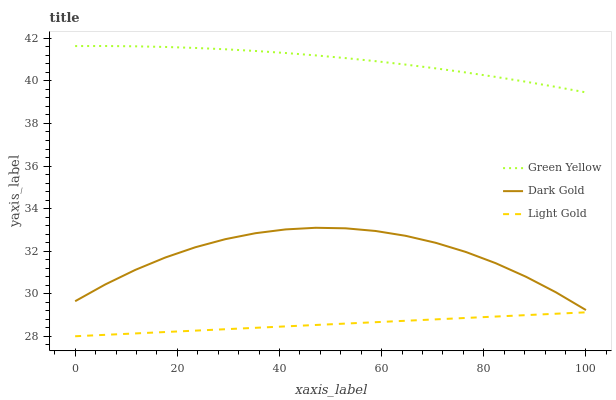Does Light Gold have the minimum area under the curve?
Answer yes or no. Yes. Does Green Yellow have the maximum area under the curve?
Answer yes or no. Yes. Does Dark Gold have the minimum area under the curve?
Answer yes or no. No. Does Dark Gold have the maximum area under the curve?
Answer yes or no. No. Is Light Gold the smoothest?
Answer yes or no. Yes. Is Dark Gold the roughest?
Answer yes or no. Yes. Is Dark Gold the smoothest?
Answer yes or no. No. Is Light Gold the roughest?
Answer yes or no. No. Does Dark Gold have the lowest value?
Answer yes or no. No. Does Green Yellow have the highest value?
Answer yes or no. Yes. Does Dark Gold have the highest value?
Answer yes or no. No. Is Light Gold less than Dark Gold?
Answer yes or no. Yes. Is Green Yellow greater than Dark Gold?
Answer yes or no. Yes. Does Light Gold intersect Dark Gold?
Answer yes or no. No. 